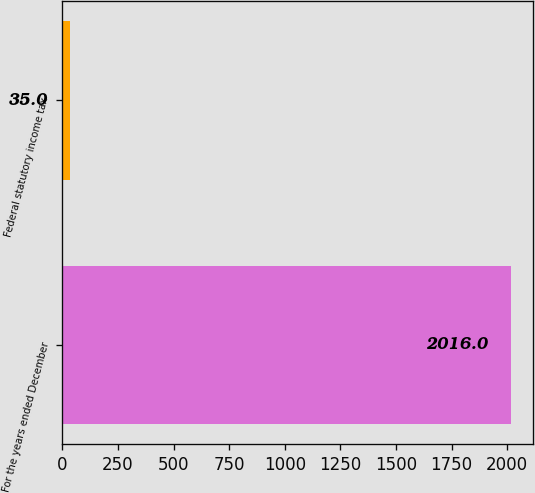<chart> <loc_0><loc_0><loc_500><loc_500><bar_chart><fcel>For the years ended December<fcel>Federal statutory income tax<nl><fcel>2016<fcel>35<nl></chart> 